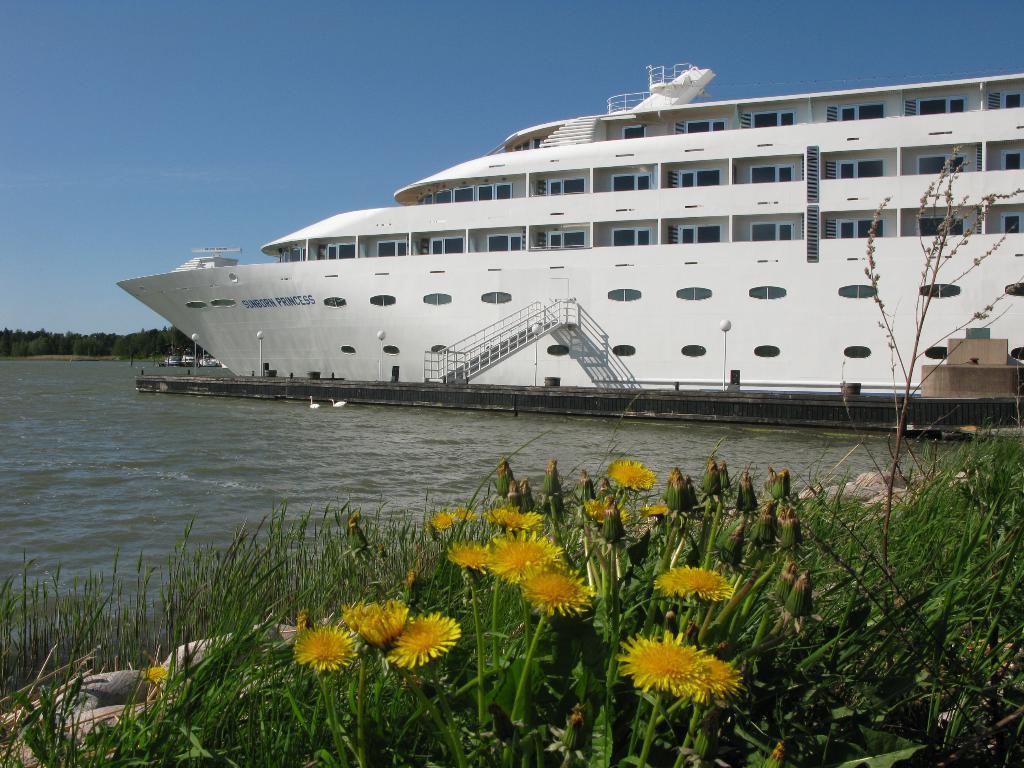Please provide a concise description of this image. In the center of the image, we can see a ship and in the background, there are plants with flowers and buds and there are trees. At the top, there is sky and at the bottom, we can see water and some birds. 